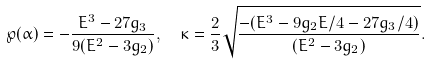Convert formula to latex. <formula><loc_0><loc_0><loc_500><loc_500>& \wp ( \alpha ) = - \frac { E ^ { 3 } - 2 7 g _ { 3 } } { 9 ( E ^ { 2 } - 3 g _ { 2 } ) } , \quad \kappa = \frac { 2 } { 3 } \sqrt { \frac { - ( E ^ { 3 } - 9 g _ { 2 } E / 4 - 2 7 g _ { 3 } / 4 ) } { ( E ^ { 2 } - 3 g _ { 2 } ) } } .</formula> 